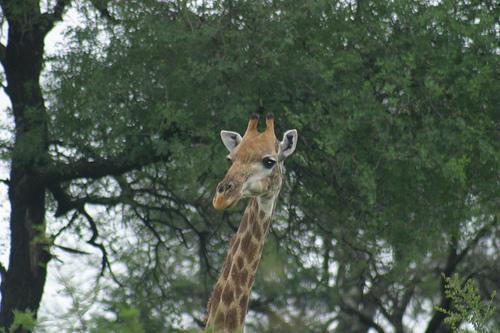How many giraffes are there?
Give a very brief answer. 1. 